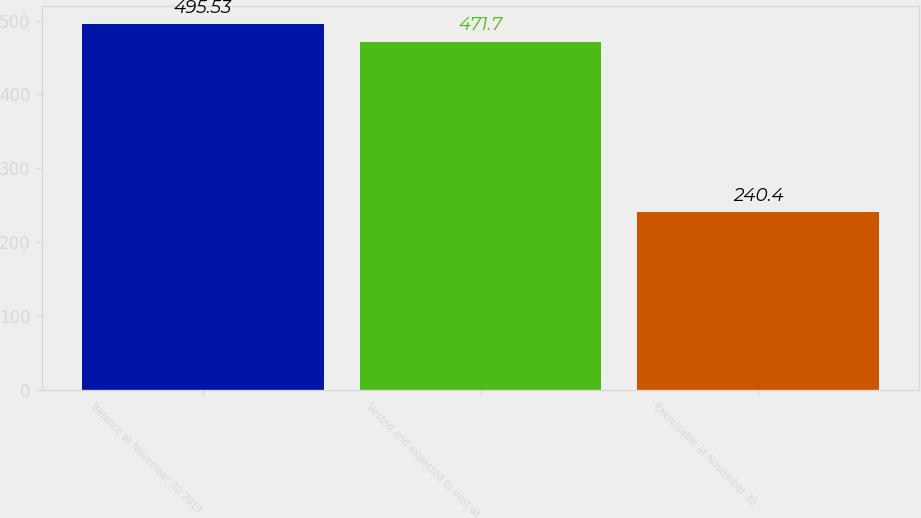Convert chart to OTSL. <chart><loc_0><loc_0><loc_500><loc_500><bar_chart><fcel>Balance at November 30 2017<fcel>Vested and expected to vest at<fcel>Exercisable at November 30<nl><fcel>495.53<fcel>471.7<fcel>240.4<nl></chart> 